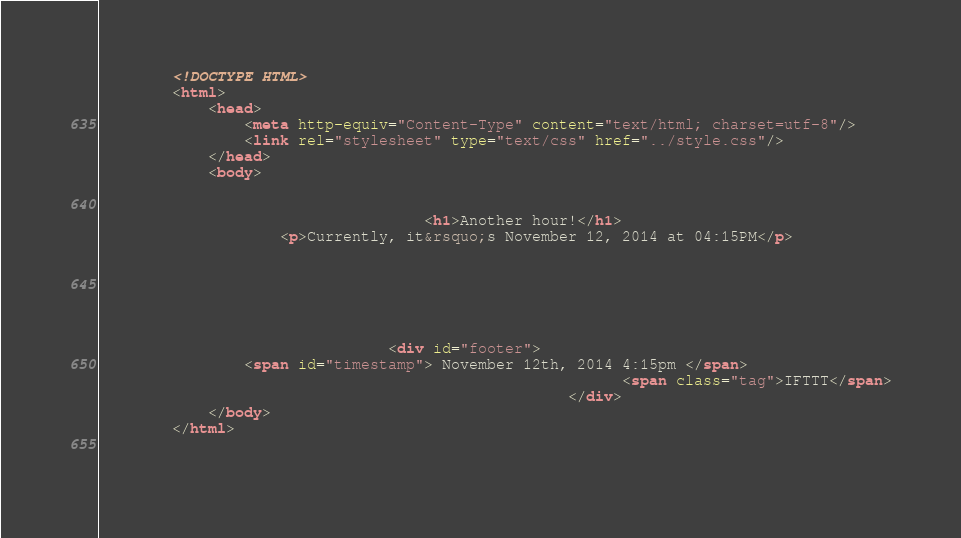<code> <loc_0><loc_0><loc_500><loc_500><_HTML_>        <!DOCTYPE HTML>
        <html>
            <head>
                <meta http-equiv="Content-Type" content="text/html; charset=utf-8"/>
                <link rel="stylesheet" type="text/css" href="../style.css"/>
            </head>
            <body>
                
                
                                    <h1>Another hour!</h1>
                    <p>Currently, it&rsquo;s November 12, 2014 at 04:15PM</p>
                
                
                
                
                
                
                                <div id="footer">
                <span id="timestamp"> November 12th, 2014 4:15pm </span>
                                                          <span class="tag">IFTTT</span>
                                                    </div>
            </body>
        </html>

        </code> 